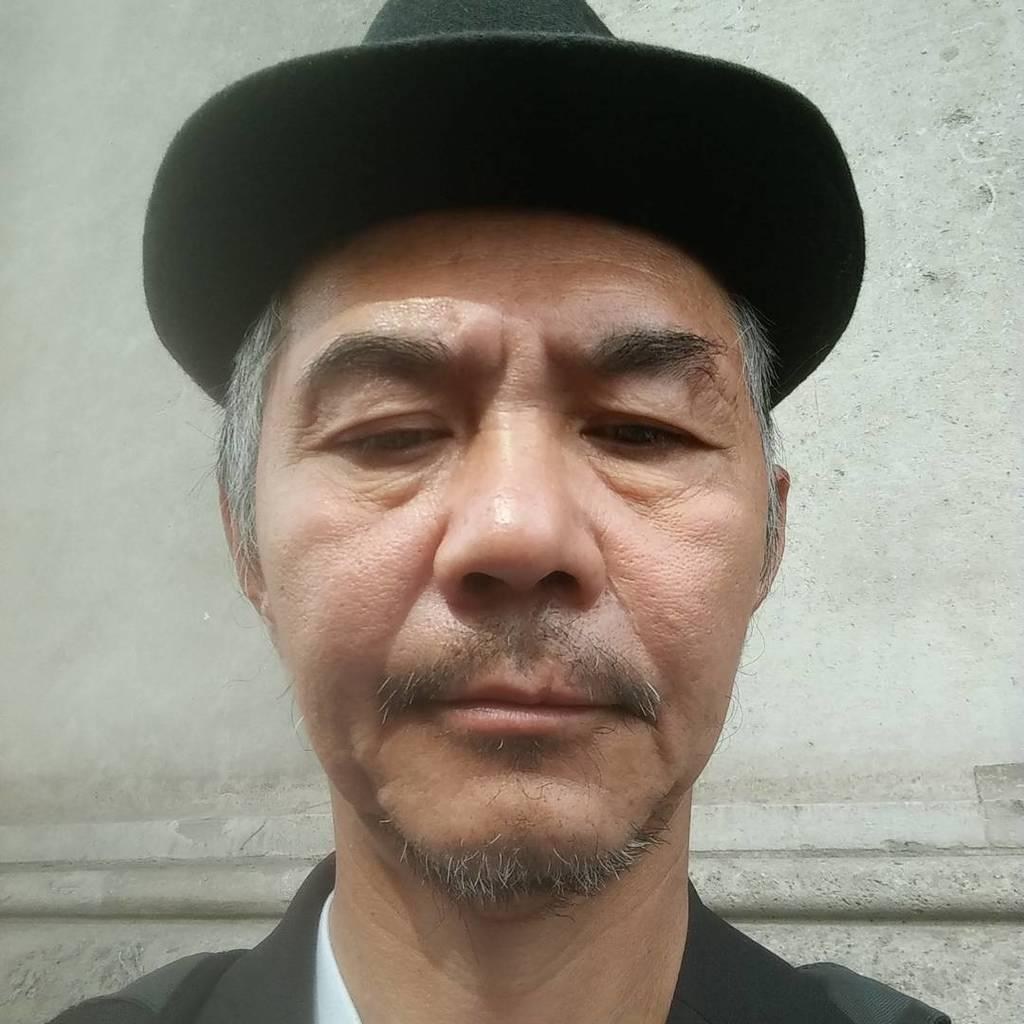What is present in the image? There is a person in the image. What is the person wearing? The person is wearing a black dress and a black hat. What type of hammer is the person holding in the image? There is no hammer present in the image; the person is only wearing a black dress and a black hat. 